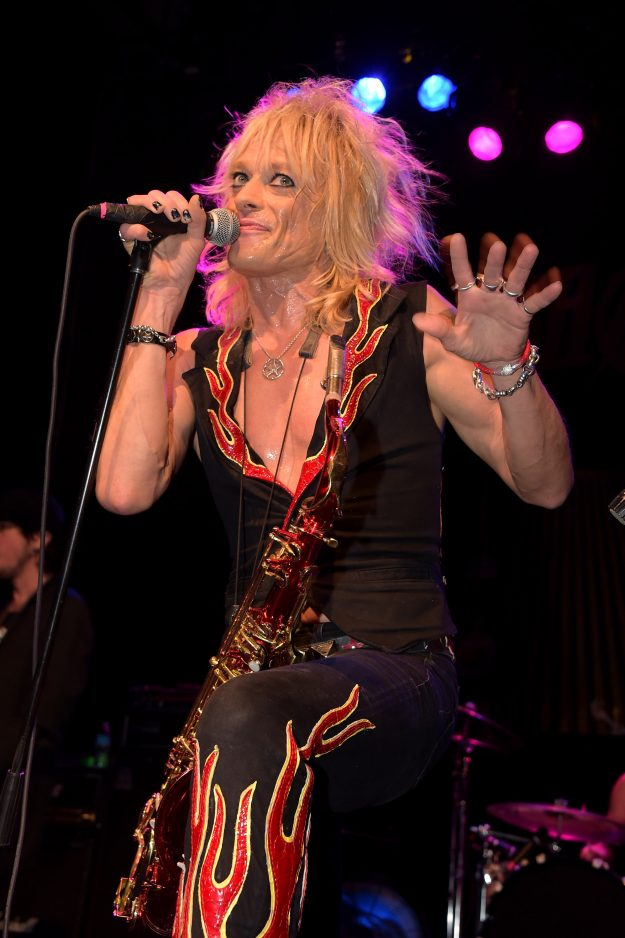If the performer could be a character in a fantasy world, based on their appearance in this image, what kind of character would they be? Based on their vibrant and edgy appearance in this image, the performer could be imagined as a rebellious fire mage in a fantasy world. This character would wield the power of flames, drawing energy from their spirited personality and dynamic presence. Their outfit, adorned with flame designs, signifies their connection to fire magic and an untamed, passionate nature. As a fire mage, they would be known for their explosive performances and ability to captivate and inspire those around them. Their accessories, like the studded bracelets and bold necklace, would be enchanted artifacts that amplify their magical abilities, allowing them to channel and manipulate fire with precision and flair. 